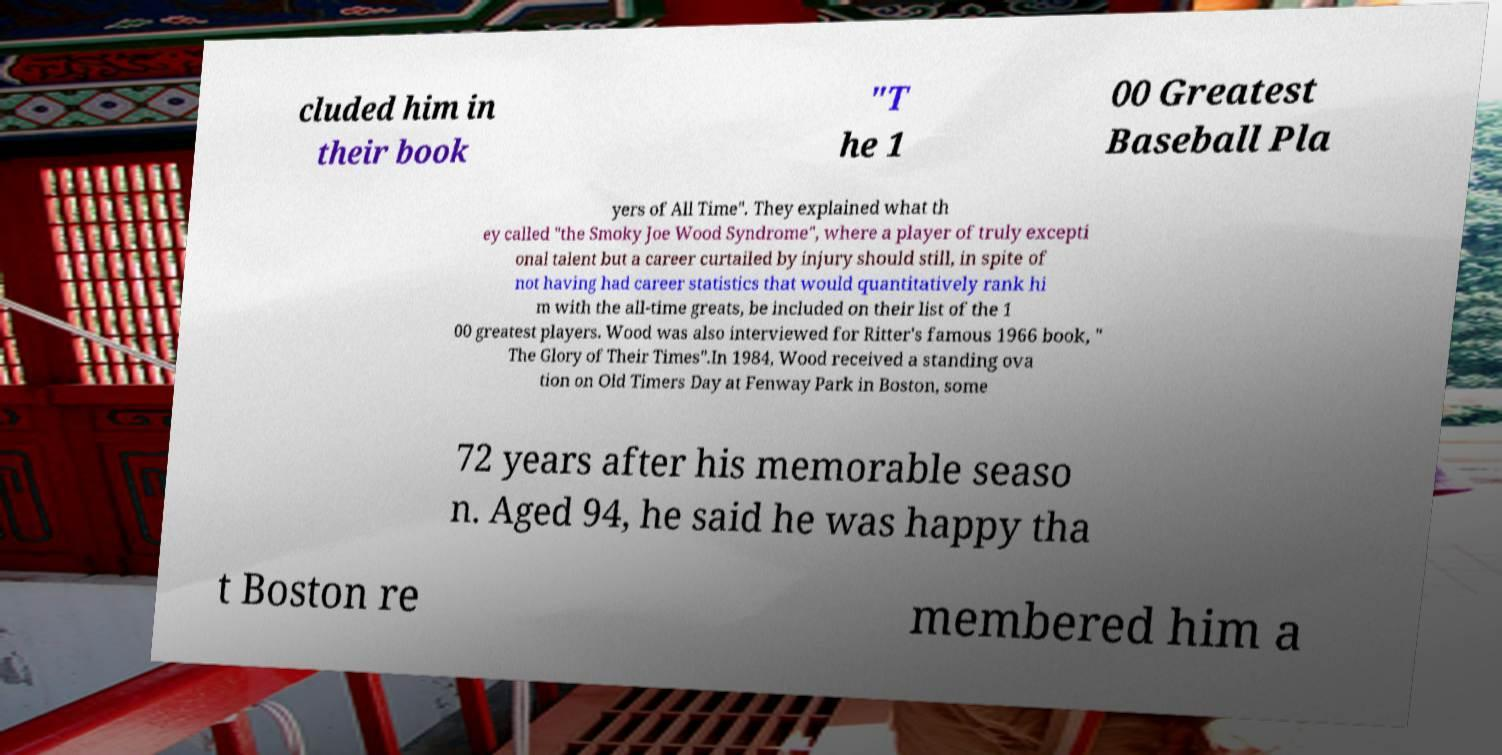There's text embedded in this image that I need extracted. Can you transcribe it verbatim? cluded him in their book "T he 1 00 Greatest Baseball Pla yers of All Time". They explained what th ey called "the Smoky Joe Wood Syndrome", where a player of truly excepti onal talent but a career curtailed by injury should still, in spite of not having had career statistics that would quantitatively rank hi m with the all-time greats, be included on their list of the 1 00 greatest players. Wood was also interviewed for Ritter's famous 1966 book, " The Glory of Their Times".In 1984, Wood received a standing ova tion on Old Timers Day at Fenway Park in Boston, some 72 years after his memorable seaso n. Aged 94, he said he was happy tha t Boston re membered him a 